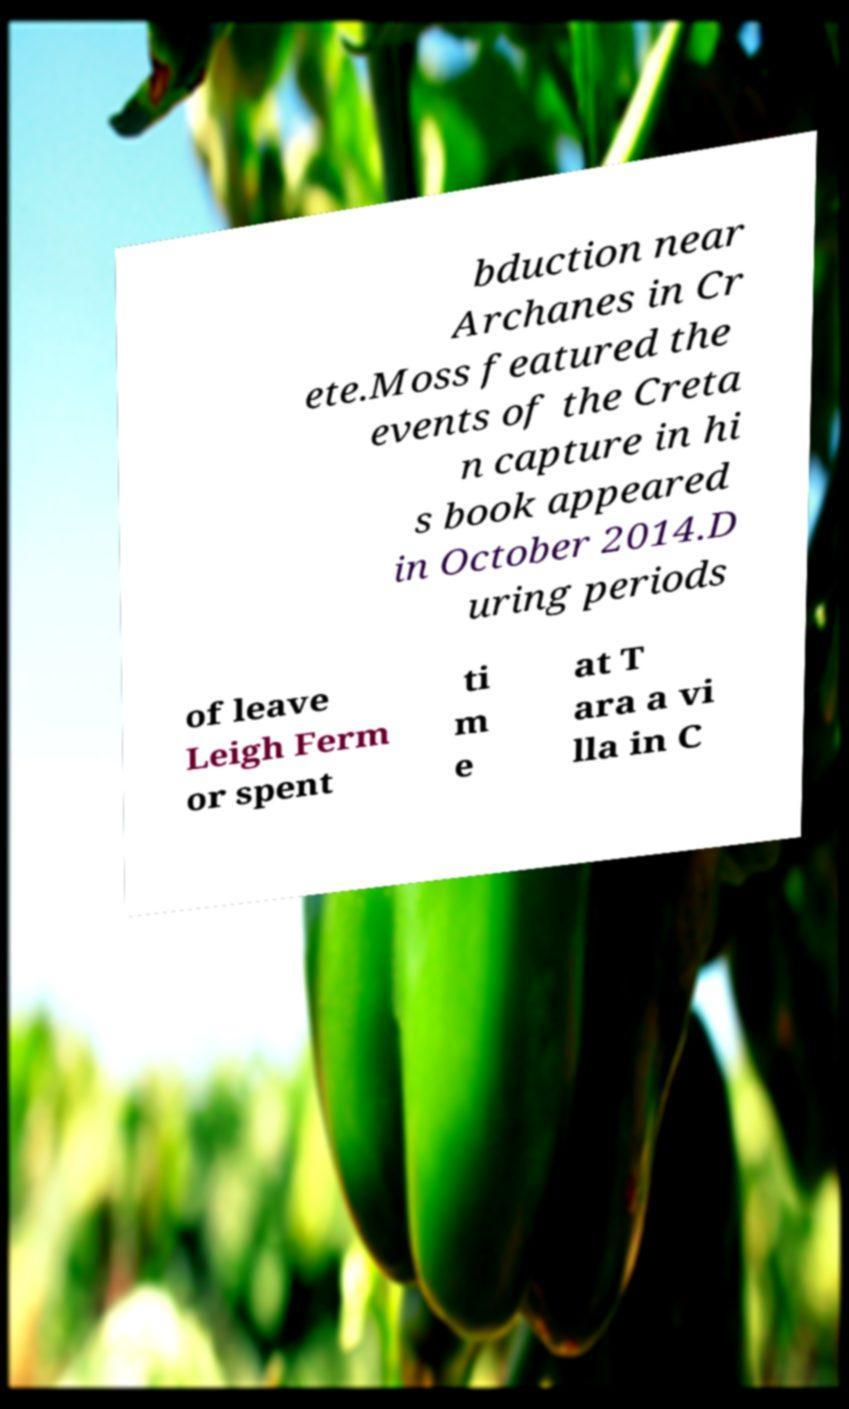Please identify and transcribe the text found in this image. bduction near Archanes in Cr ete.Moss featured the events of the Creta n capture in hi s book appeared in October 2014.D uring periods of leave Leigh Ferm or spent ti m e at T ara a vi lla in C 